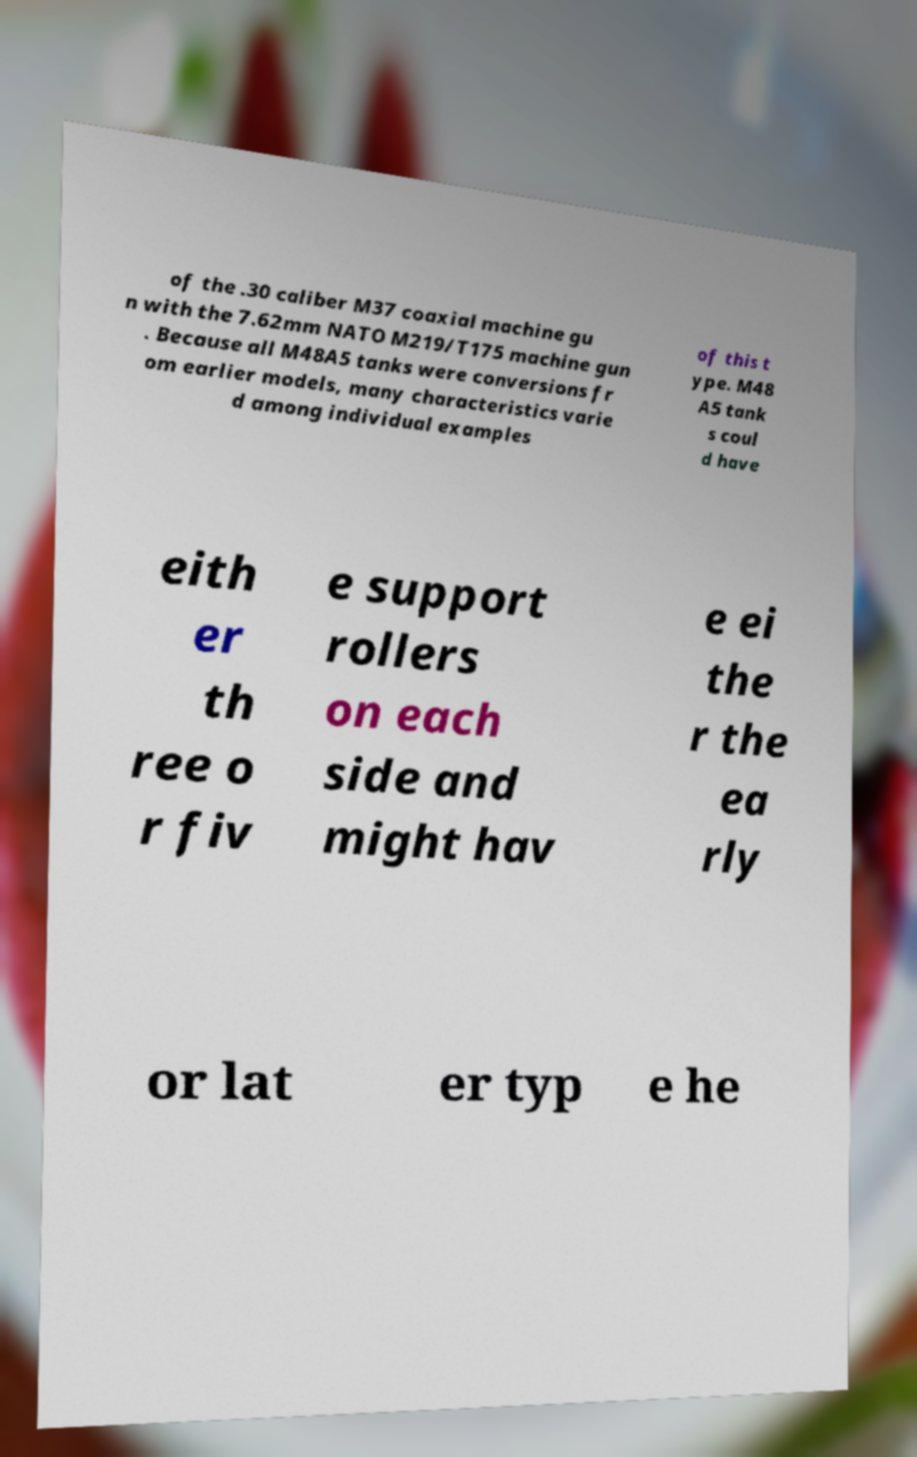Please read and relay the text visible in this image. What does it say? of the .30 caliber M37 coaxial machine gu n with the 7.62mm NATO M219/T175 machine gun . Because all M48A5 tanks were conversions fr om earlier models, many characteristics varie d among individual examples of this t ype. M48 A5 tank s coul d have eith er th ree o r fiv e support rollers on each side and might hav e ei the r the ea rly or lat er typ e he 